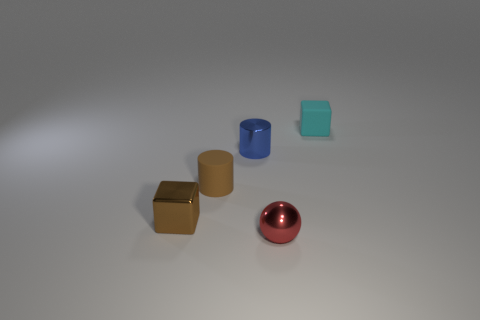Add 2 small gray things. How many objects exist? 7 Subtract all spheres. How many objects are left? 4 Add 5 small metal cylinders. How many small metal cylinders are left? 6 Add 5 red metallic objects. How many red metallic objects exist? 6 Subtract 0 green cylinders. How many objects are left? 5 Subtract all small cyan rubber things. Subtract all blue shiny things. How many objects are left? 3 